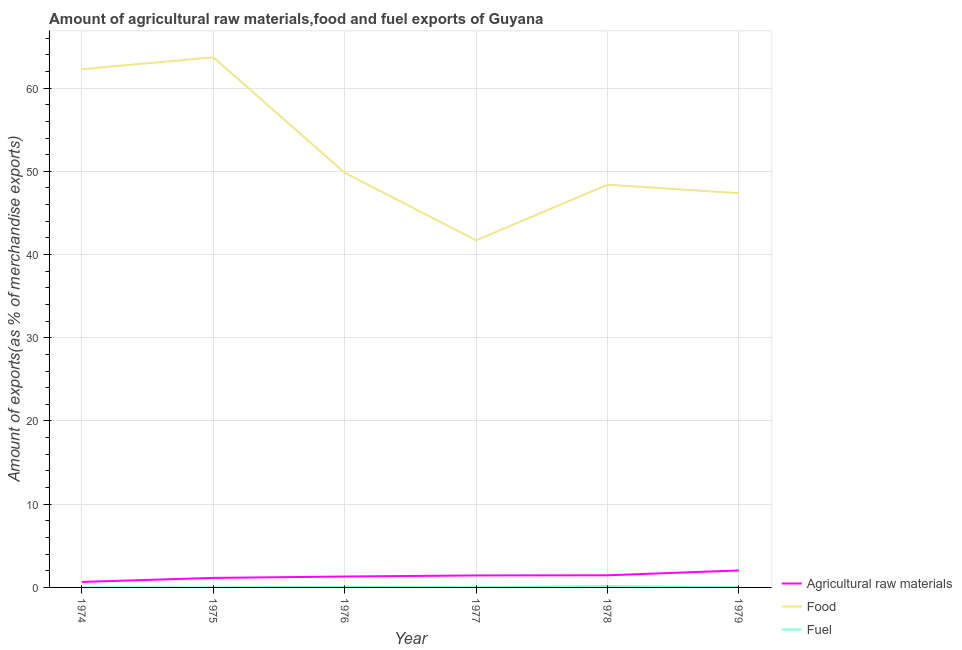Does the line corresponding to percentage of food exports intersect with the line corresponding to percentage of raw materials exports?
Make the answer very short. No. What is the percentage of fuel exports in 1979?
Your response must be concise. 0.03. Across all years, what is the maximum percentage of raw materials exports?
Offer a very short reply. 2.04. Across all years, what is the minimum percentage of fuel exports?
Your answer should be compact. 0. In which year was the percentage of fuel exports maximum?
Make the answer very short. 1978. In which year was the percentage of fuel exports minimum?
Your response must be concise. 1974. What is the total percentage of fuel exports in the graph?
Give a very brief answer. 0.27. What is the difference between the percentage of raw materials exports in 1975 and that in 1976?
Your response must be concise. -0.17. What is the difference between the percentage of fuel exports in 1977 and the percentage of raw materials exports in 1978?
Your answer should be compact. -1.44. What is the average percentage of raw materials exports per year?
Your answer should be compact. 1.34. In the year 1979, what is the difference between the percentage of food exports and percentage of raw materials exports?
Keep it short and to the point. 45.33. What is the ratio of the percentage of fuel exports in 1978 to that in 1979?
Provide a succinct answer. 6.14. Is the percentage of food exports in 1974 less than that in 1979?
Make the answer very short. No. Is the difference between the percentage of fuel exports in 1974 and 1977 greater than the difference between the percentage of raw materials exports in 1974 and 1977?
Keep it short and to the point. Yes. What is the difference between the highest and the second highest percentage of raw materials exports?
Make the answer very short. 0.58. What is the difference between the highest and the lowest percentage of fuel exports?
Give a very brief answer. 0.16. Is the sum of the percentage of fuel exports in 1974 and 1976 greater than the maximum percentage of raw materials exports across all years?
Give a very brief answer. No. Is it the case that in every year, the sum of the percentage of raw materials exports and percentage of food exports is greater than the percentage of fuel exports?
Offer a very short reply. Yes. How many lines are there?
Keep it short and to the point. 3. How many years are there in the graph?
Make the answer very short. 6. Are the values on the major ticks of Y-axis written in scientific E-notation?
Offer a very short reply. No. Does the graph contain any zero values?
Make the answer very short. No. How many legend labels are there?
Offer a very short reply. 3. How are the legend labels stacked?
Your answer should be compact. Vertical. What is the title of the graph?
Your response must be concise. Amount of agricultural raw materials,food and fuel exports of Guyana. What is the label or title of the X-axis?
Provide a succinct answer. Year. What is the label or title of the Y-axis?
Your answer should be very brief. Amount of exports(as % of merchandise exports). What is the Amount of exports(as % of merchandise exports) in Agricultural raw materials in 1974?
Your answer should be compact. 0.66. What is the Amount of exports(as % of merchandise exports) in Food in 1974?
Offer a terse response. 62.28. What is the Amount of exports(as % of merchandise exports) in Fuel in 1974?
Provide a succinct answer. 0. What is the Amount of exports(as % of merchandise exports) in Agricultural raw materials in 1975?
Offer a very short reply. 1.14. What is the Amount of exports(as % of merchandise exports) of Food in 1975?
Provide a succinct answer. 63.7. What is the Amount of exports(as % of merchandise exports) in Fuel in 1975?
Keep it short and to the point. 0. What is the Amount of exports(as % of merchandise exports) of Agricultural raw materials in 1976?
Your answer should be very brief. 1.31. What is the Amount of exports(as % of merchandise exports) of Food in 1976?
Offer a very short reply. 49.82. What is the Amount of exports(as % of merchandise exports) of Fuel in 1976?
Provide a succinct answer. 0.07. What is the Amount of exports(as % of merchandise exports) in Agricultural raw materials in 1977?
Your answer should be compact. 1.44. What is the Amount of exports(as % of merchandise exports) in Food in 1977?
Keep it short and to the point. 41.71. What is the Amount of exports(as % of merchandise exports) in Fuel in 1977?
Your answer should be compact. 0.02. What is the Amount of exports(as % of merchandise exports) in Agricultural raw materials in 1978?
Offer a very short reply. 1.46. What is the Amount of exports(as % of merchandise exports) of Food in 1978?
Make the answer very short. 48.39. What is the Amount of exports(as % of merchandise exports) in Fuel in 1978?
Provide a succinct answer. 0.16. What is the Amount of exports(as % of merchandise exports) of Agricultural raw materials in 1979?
Ensure brevity in your answer.  2.04. What is the Amount of exports(as % of merchandise exports) in Food in 1979?
Give a very brief answer. 47.37. What is the Amount of exports(as % of merchandise exports) in Fuel in 1979?
Give a very brief answer. 0.03. Across all years, what is the maximum Amount of exports(as % of merchandise exports) of Agricultural raw materials?
Keep it short and to the point. 2.04. Across all years, what is the maximum Amount of exports(as % of merchandise exports) of Food?
Your response must be concise. 63.7. Across all years, what is the maximum Amount of exports(as % of merchandise exports) of Fuel?
Keep it short and to the point. 0.16. Across all years, what is the minimum Amount of exports(as % of merchandise exports) in Agricultural raw materials?
Your response must be concise. 0.66. Across all years, what is the minimum Amount of exports(as % of merchandise exports) of Food?
Your response must be concise. 41.71. Across all years, what is the minimum Amount of exports(as % of merchandise exports) of Fuel?
Your response must be concise. 0. What is the total Amount of exports(as % of merchandise exports) of Agricultural raw materials in the graph?
Your response must be concise. 8.05. What is the total Amount of exports(as % of merchandise exports) of Food in the graph?
Offer a very short reply. 313.27. What is the total Amount of exports(as % of merchandise exports) of Fuel in the graph?
Make the answer very short. 0.27. What is the difference between the Amount of exports(as % of merchandise exports) in Agricultural raw materials in 1974 and that in 1975?
Your answer should be compact. -0.48. What is the difference between the Amount of exports(as % of merchandise exports) in Food in 1974 and that in 1975?
Give a very brief answer. -1.42. What is the difference between the Amount of exports(as % of merchandise exports) in Fuel in 1974 and that in 1975?
Offer a very short reply. -0. What is the difference between the Amount of exports(as % of merchandise exports) of Agricultural raw materials in 1974 and that in 1976?
Your answer should be very brief. -0.65. What is the difference between the Amount of exports(as % of merchandise exports) of Food in 1974 and that in 1976?
Your answer should be compact. 12.46. What is the difference between the Amount of exports(as % of merchandise exports) of Fuel in 1974 and that in 1976?
Offer a very short reply. -0.07. What is the difference between the Amount of exports(as % of merchandise exports) in Agricultural raw materials in 1974 and that in 1977?
Provide a short and direct response. -0.78. What is the difference between the Amount of exports(as % of merchandise exports) of Food in 1974 and that in 1977?
Your answer should be compact. 20.57. What is the difference between the Amount of exports(as % of merchandise exports) of Fuel in 1974 and that in 1977?
Your answer should be very brief. -0.02. What is the difference between the Amount of exports(as % of merchandise exports) in Agricultural raw materials in 1974 and that in 1978?
Ensure brevity in your answer.  -0.8. What is the difference between the Amount of exports(as % of merchandise exports) in Food in 1974 and that in 1978?
Offer a very short reply. 13.89. What is the difference between the Amount of exports(as % of merchandise exports) in Fuel in 1974 and that in 1978?
Provide a succinct answer. -0.16. What is the difference between the Amount of exports(as % of merchandise exports) of Agricultural raw materials in 1974 and that in 1979?
Ensure brevity in your answer.  -1.38. What is the difference between the Amount of exports(as % of merchandise exports) in Food in 1974 and that in 1979?
Offer a terse response. 14.91. What is the difference between the Amount of exports(as % of merchandise exports) of Fuel in 1974 and that in 1979?
Keep it short and to the point. -0.03. What is the difference between the Amount of exports(as % of merchandise exports) of Agricultural raw materials in 1975 and that in 1976?
Your response must be concise. -0.17. What is the difference between the Amount of exports(as % of merchandise exports) in Food in 1975 and that in 1976?
Provide a succinct answer. 13.88. What is the difference between the Amount of exports(as % of merchandise exports) of Fuel in 1975 and that in 1976?
Ensure brevity in your answer.  -0.07. What is the difference between the Amount of exports(as % of merchandise exports) of Agricultural raw materials in 1975 and that in 1977?
Give a very brief answer. -0.3. What is the difference between the Amount of exports(as % of merchandise exports) of Food in 1975 and that in 1977?
Make the answer very short. 21.99. What is the difference between the Amount of exports(as % of merchandise exports) in Fuel in 1975 and that in 1977?
Offer a very short reply. -0.02. What is the difference between the Amount of exports(as % of merchandise exports) in Agricultural raw materials in 1975 and that in 1978?
Keep it short and to the point. -0.31. What is the difference between the Amount of exports(as % of merchandise exports) in Food in 1975 and that in 1978?
Provide a short and direct response. 15.31. What is the difference between the Amount of exports(as % of merchandise exports) in Fuel in 1975 and that in 1978?
Make the answer very short. -0.16. What is the difference between the Amount of exports(as % of merchandise exports) in Agricultural raw materials in 1975 and that in 1979?
Your answer should be compact. -0.9. What is the difference between the Amount of exports(as % of merchandise exports) of Food in 1975 and that in 1979?
Your answer should be very brief. 16.33. What is the difference between the Amount of exports(as % of merchandise exports) in Fuel in 1975 and that in 1979?
Give a very brief answer. -0.03. What is the difference between the Amount of exports(as % of merchandise exports) in Agricultural raw materials in 1976 and that in 1977?
Offer a very short reply. -0.13. What is the difference between the Amount of exports(as % of merchandise exports) in Food in 1976 and that in 1977?
Give a very brief answer. 8.11. What is the difference between the Amount of exports(as % of merchandise exports) in Fuel in 1976 and that in 1977?
Give a very brief answer. 0.05. What is the difference between the Amount of exports(as % of merchandise exports) of Agricultural raw materials in 1976 and that in 1978?
Your answer should be compact. -0.15. What is the difference between the Amount of exports(as % of merchandise exports) of Food in 1976 and that in 1978?
Provide a succinct answer. 1.43. What is the difference between the Amount of exports(as % of merchandise exports) in Fuel in 1976 and that in 1978?
Offer a very short reply. -0.09. What is the difference between the Amount of exports(as % of merchandise exports) of Agricultural raw materials in 1976 and that in 1979?
Offer a very short reply. -0.73. What is the difference between the Amount of exports(as % of merchandise exports) in Food in 1976 and that in 1979?
Your answer should be compact. 2.45. What is the difference between the Amount of exports(as % of merchandise exports) of Fuel in 1976 and that in 1979?
Give a very brief answer. 0.04. What is the difference between the Amount of exports(as % of merchandise exports) of Agricultural raw materials in 1977 and that in 1978?
Your answer should be compact. -0.02. What is the difference between the Amount of exports(as % of merchandise exports) of Food in 1977 and that in 1978?
Offer a very short reply. -6.68. What is the difference between the Amount of exports(as % of merchandise exports) of Fuel in 1977 and that in 1978?
Offer a very short reply. -0.14. What is the difference between the Amount of exports(as % of merchandise exports) of Agricultural raw materials in 1977 and that in 1979?
Your response must be concise. -0.6. What is the difference between the Amount of exports(as % of merchandise exports) in Food in 1977 and that in 1979?
Give a very brief answer. -5.66. What is the difference between the Amount of exports(as % of merchandise exports) in Fuel in 1977 and that in 1979?
Ensure brevity in your answer.  -0. What is the difference between the Amount of exports(as % of merchandise exports) of Agricultural raw materials in 1978 and that in 1979?
Make the answer very short. -0.58. What is the difference between the Amount of exports(as % of merchandise exports) in Food in 1978 and that in 1979?
Your response must be concise. 1.02. What is the difference between the Amount of exports(as % of merchandise exports) of Fuel in 1978 and that in 1979?
Offer a terse response. 0.13. What is the difference between the Amount of exports(as % of merchandise exports) of Agricultural raw materials in 1974 and the Amount of exports(as % of merchandise exports) of Food in 1975?
Your answer should be compact. -63.04. What is the difference between the Amount of exports(as % of merchandise exports) in Agricultural raw materials in 1974 and the Amount of exports(as % of merchandise exports) in Fuel in 1975?
Give a very brief answer. 0.66. What is the difference between the Amount of exports(as % of merchandise exports) of Food in 1974 and the Amount of exports(as % of merchandise exports) of Fuel in 1975?
Your answer should be very brief. 62.28. What is the difference between the Amount of exports(as % of merchandise exports) of Agricultural raw materials in 1974 and the Amount of exports(as % of merchandise exports) of Food in 1976?
Give a very brief answer. -49.16. What is the difference between the Amount of exports(as % of merchandise exports) in Agricultural raw materials in 1974 and the Amount of exports(as % of merchandise exports) in Fuel in 1976?
Give a very brief answer. 0.59. What is the difference between the Amount of exports(as % of merchandise exports) in Food in 1974 and the Amount of exports(as % of merchandise exports) in Fuel in 1976?
Offer a terse response. 62.21. What is the difference between the Amount of exports(as % of merchandise exports) of Agricultural raw materials in 1974 and the Amount of exports(as % of merchandise exports) of Food in 1977?
Ensure brevity in your answer.  -41.05. What is the difference between the Amount of exports(as % of merchandise exports) in Agricultural raw materials in 1974 and the Amount of exports(as % of merchandise exports) in Fuel in 1977?
Make the answer very short. 0.64. What is the difference between the Amount of exports(as % of merchandise exports) in Food in 1974 and the Amount of exports(as % of merchandise exports) in Fuel in 1977?
Ensure brevity in your answer.  62.26. What is the difference between the Amount of exports(as % of merchandise exports) of Agricultural raw materials in 1974 and the Amount of exports(as % of merchandise exports) of Food in 1978?
Your response must be concise. -47.73. What is the difference between the Amount of exports(as % of merchandise exports) of Agricultural raw materials in 1974 and the Amount of exports(as % of merchandise exports) of Fuel in 1978?
Make the answer very short. 0.5. What is the difference between the Amount of exports(as % of merchandise exports) of Food in 1974 and the Amount of exports(as % of merchandise exports) of Fuel in 1978?
Keep it short and to the point. 62.12. What is the difference between the Amount of exports(as % of merchandise exports) of Agricultural raw materials in 1974 and the Amount of exports(as % of merchandise exports) of Food in 1979?
Make the answer very short. -46.71. What is the difference between the Amount of exports(as % of merchandise exports) of Agricultural raw materials in 1974 and the Amount of exports(as % of merchandise exports) of Fuel in 1979?
Make the answer very short. 0.63. What is the difference between the Amount of exports(as % of merchandise exports) of Food in 1974 and the Amount of exports(as % of merchandise exports) of Fuel in 1979?
Give a very brief answer. 62.25. What is the difference between the Amount of exports(as % of merchandise exports) in Agricultural raw materials in 1975 and the Amount of exports(as % of merchandise exports) in Food in 1976?
Keep it short and to the point. -48.68. What is the difference between the Amount of exports(as % of merchandise exports) of Agricultural raw materials in 1975 and the Amount of exports(as % of merchandise exports) of Fuel in 1976?
Your answer should be very brief. 1.08. What is the difference between the Amount of exports(as % of merchandise exports) in Food in 1975 and the Amount of exports(as % of merchandise exports) in Fuel in 1976?
Make the answer very short. 63.63. What is the difference between the Amount of exports(as % of merchandise exports) in Agricultural raw materials in 1975 and the Amount of exports(as % of merchandise exports) in Food in 1977?
Give a very brief answer. -40.56. What is the difference between the Amount of exports(as % of merchandise exports) in Agricultural raw materials in 1975 and the Amount of exports(as % of merchandise exports) in Fuel in 1977?
Your response must be concise. 1.12. What is the difference between the Amount of exports(as % of merchandise exports) in Food in 1975 and the Amount of exports(as % of merchandise exports) in Fuel in 1977?
Your response must be concise. 63.68. What is the difference between the Amount of exports(as % of merchandise exports) of Agricultural raw materials in 1975 and the Amount of exports(as % of merchandise exports) of Food in 1978?
Make the answer very short. -47.25. What is the difference between the Amount of exports(as % of merchandise exports) of Agricultural raw materials in 1975 and the Amount of exports(as % of merchandise exports) of Fuel in 1978?
Your answer should be very brief. 0.99. What is the difference between the Amount of exports(as % of merchandise exports) in Food in 1975 and the Amount of exports(as % of merchandise exports) in Fuel in 1978?
Provide a short and direct response. 63.54. What is the difference between the Amount of exports(as % of merchandise exports) of Agricultural raw materials in 1975 and the Amount of exports(as % of merchandise exports) of Food in 1979?
Provide a short and direct response. -46.23. What is the difference between the Amount of exports(as % of merchandise exports) in Agricultural raw materials in 1975 and the Amount of exports(as % of merchandise exports) in Fuel in 1979?
Your answer should be very brief. 1.12. What is the difference between the Amount of exports(as % of merchandise exports) in Food in 1975 and the Amount of exports(as % of merchandise exports) in Fuel in 1979?
Give a very brief answer. 63.67. What is the difference between the Amount of exports(as % of merchandise exports) of Agricultural raw materials in 1976 and the Amount of exports(as % of merchandise exports) of Food in 1977?
Give a very brief answer. -40.4. What is the difference between the Amount of exports(as % of merchandise exports) of Agricultural raw materials in 1976 and the Amount of exports(as % of merchandise exports) of Fuel in 1977?
Your answer should be compact. 1.29. What is the difference between the Amount of exports(as % of merchandise exports) of Food in 1976 and the Amount of exports(as % of merchandise exports) of Fuel in 1977?
Provide a short and direct response. 49.8. What is the difference between the Amount of exports(as % of merchandise exports) of Agricultural raw materials in 1976 and the Amount of exports(as % of merchandise exports) of Food in 1978?
Ensure brevity in your answer.  -47.08. What is the difference between the Amount of exports(as % of merchandise exports) of Agricultural raw materials in 1976 and the Amount of exports(as % of merchandise exports) of Fuel in 1978?
Give a very brief answer. 1.15. What is the difference between the Amount of exports(as % of merchandise exports) in Food in 1976 and the Amount of exports(as % of merchandise exports) in Fuel in 1978?
Your answer should be very brief. 49.66. What is the difference between the Amount of exports(as % of merchandise exports) in Agricultural raw materials in 1976 and the Amount of exports(as % of merchandise exports) in Food in 1979?
Provide a succinct answer. -46.06. What is the difference between the Amount of exports(as % of merchandise exports) in Agricultural raw materials in 1976 and the Amount of exports(as % of merchandise exports) in Fuel in 1979?
Offer a terse response. 1.29. What is the difference between the Amount of exports(as % of merchandise exports) in Food in 1976 and the Amount of exports(as % of merchandise exports) in Fuel in 1979?
Make the answer very short. 49.8. What is the difference between the Amount of exports(as % of merchandise exports) in Agricultural raw materials in 1977 and the Amount of exports(as % of merchandise exports) in Food in 1978?
Provide a short and direct response. -46.95. What is the difference between the Amount of exports(as % of merchandise exports) of Agricultural raw materials in 1977 and the Amount of exports(as % of merchandise exports) of Fuel in 1978?
Offer a terse response. 1.28. What is the difference between the Amount of exports(as % of merchandise exports) of Food in 1977 and the Amount of exports(as % of merchandise exports) of Fuel in 1978?
Your response must be concise. 41.55. What is the difference between the Amount of exports(as % of merchandise exports) of Agricultural raw materials in 1977 and the Amount of exports(as % of merchandise exports) of Food in 1979?
Make the answer very short. -45.93. What is the difference between the Amount of exports(as % of merchandise exports) of Agricultural raw materials in 1977 and the Amount of exports(as % of merchandise exports) of Fuel in 1979?
Ensure brevity in your answer.  1.42. What is the difference between the Amount of exports(as % of merchandise exports) of Food in 1977 and the Amount of exports(as % of merchandise exports) of Fuel in 1979?
Make the answer very short. 41.68. What is the difference between the Amount of exports(as % of merchandise exports) in Agricultural raw materials in 1978 and the Amount of exports(as % of merchandise exports) in Food in 1979?
Your answer should be compact. -45.91. What is the difference between the Amount of exports(as % of merchandise exports) of Agricultural raw materials in 1978 and the Amount of exports(as % of merchandise exports) of Fuel in 1979?
Keep it short and to the point. 1.43. What is the difference between the Amount of exports(as % of merchandise exports) in Food in 1978 and the Amount of exports(as % of merchandise exports) in Fuel in 1979?
Give a very brief answer. 48.37. What is the average Amount of exports(as % of merchandise exports) in Agricultural raw materials per year?
Your answer should be very brief. 1.34. What is the average Amount of exports(as % of merchandise exports) in Food per year?
Your answer should be very brief. 52.21. What is the average Amount of exports(as % of merchandise exports) of Fuel per year?
Your response must be concise. 0.04. In the year 1974, what is the difference between the Amount of exports(as % of merchandise exports) in Agricultural raw materials and Amount of exports(as % of merchandise exports) in Food?
Provide a short and direct response. -61.62. In the year 1974, what is the difference between the Amount of exports(as % of merchandise exports) of Agricultural raw materials and Amount of exports(as % of merchandise exports) of Fuel?
Ensure brevity in your answer.  0.66. In the year 1974, what is the difference between the Amount of exports(as % of merchandise exports) in Food and Amount of exports(as % of merchandise exports) in Fuel?
Give a very brief answer. 62.28. In the year 1975, what is the difference between the Amount of exports(as % of merchandise exports) of Agricultural raw materials and Amount of exports(as % of merchandise exports) of Food?
Your response must be concise. -62.55. In the year 1975, what is the difference between the Amount of exports(as % of merchandise exports) of Agricultural raw materials and Amount of exports(as % of merchandise exports) of Fuel?
Provide a succinct answer. 1.14. In the year 1975, what is the difference between the Amount of exports(as % of merchandise exports) in Food and Amount of exports(as % of merchandise exports) in Fuel?
Give a very brief answer. 63.7. In the year 1976, what is the difference between the Amount of exports(as % of merchandise exports) in Agricultural raw materials and Amount of exports(as % of merchandise exports) in Food?
Ensure brevity in your answer.  -48.51. In the year 1976, what is the difference between the Amount of exports(as % of merchandise exports) of Agricultural raw materials and Amount of exports(as % of merchandise exports) of Fuel?
Ensure brevity in your answer.  1.25. In the year 1976, what is the difference between the Amount of exports(as % of merchandise exports) in Food and Amount of exports(as % of merchandise exports) in Fuel?
Your response must be concise. 49.76. In the year 1977, what is the difference between the Amount of exports(as % of merchandise exports) of Agricultural raw materials and Amount of exports(as % of merchandise exports) of Food?
Make the answer very short. -40.27. In the year 1977, what is the difference between the Amount of exports(as % of merchandise exports) in Agricultural raw materials and Amount of exports(as % of merchandise exports) in Fuel?
Offer a terse response. 1.42. In the year 1977, what is the difference between the Amount of exports(as % of merchandise exports) in Food and Amount of exports(as % of merchandise exports) in Fuel?
Provide a short and direct response. 41.69. In the year 1978, what is the difference between the Amount of exports(as % of merchandise exports) of Agricultural raw materials and Amount of exports(as % of merchandise exports) of Food?
Give a very brief answer. -46.94. In the year 1978, what is the difference between the Amount of exports(as % of merchandise exports) in Agricultural raw materials and Amount of exports(as % of merchandise exports) in Fuel?
Offer a very short reply. 1.3. In the year 1978, what is the difference between the Amount of exports(as % of merchandise exports) in Food and Amount of exports(as % of merchandise exports) in Fuel?
Your answer should be compact. 48.24. In the year 1979, what is the difference between the Amount of exports(as % of merchandise exports) in Agricultural raw materials and Amount of exports(as % of merchandise exports) in Food?
Provide a succinct answer. -45.33. In the year 1979, what is the difference between the Amount of exports(as % of merchandise exports) in Agricultural raw materials and Amount of exports(as % of merchandise exports) in Fuel?
Give a very brief answer. 2.01. In the year 1979, what is the difference between the Amount of exports(as % of merchandise exports) in Food and Amount of exports(as % of merchandise exports) in Fuel?
Provide a short and direct response. 47.34. What is the ratio of the Amount of exports(as % of merchandise exports) of Agricultural raw materials in 1974 to that in 1975?
Your answer should be very brief. 0.58. What is the ratio of the Amount of exports(as % of merchandise exports) of Food in 1974 to that in 1975?
Provide a succinct answer. 0.98. What is the ratio of the Amount of exports(as % of merchandise exports) of Fuel in 1974 to that in 1975?
Your answer should be very brief. 0.52. What is the ratio of the Amount of exports(as % of merchandise exports) of Agricultural raw materials in 1974 to that in 1976?
Provide a short and direct response. 0.5. What is the ratio of the Amount of exports(as % of merchandise exports) in Food in 1974 to that in 1976?
Provide a short and direct response. 1.25. What is the ratio of the Amount of exports(as % of merchandise exports) in Fuel in 1974 to that in 1976?
Ensure brevity in your answer.  0. What is the ratio of the Amount of exports(as % of merchandise exports) of Agricultural raw materials in 1974 to that in 1977?
Your response must be concise. 0.46. What is the ratio of the Amount of exports(as % of merchandise exports) in Food in 1974 to that in 1977?
Ensure brevity in your answer.  1.49. What is the ratio of the Amount of exports(as % of merchandise exports) in Fuel in 1974 to that in 1977?
Your response must be concise. 0.01. What is the ratio of the Amount of exports(as % of merchandise exports) in Agricultural raw materials in 1974 to that in 1978?
Ensure brevity in your answer.  0.45. What is the ratio of the Amount of exports(as % of merchandise exports) of Food in 1974 to that in 1978?
Provide a short and direct response. 1.29. What is the ratio of the Amount of exports(as % of merchandise exports) in Fuel in 1974 to that in 1978?
Keep it short and to the point. 0. What is the ratio of the Amount of exports(as % of merchandise exports) in Agricultural raw materials in 1974 to that in 1979?
Provide a short and direct response. 0.32. What is the ratio of the Amount of exports(as % of merchandise exports) in Food in 1974 to that in 1979?
Offer a very short reply. 1.31. What is the ratio of the Amount of exports(as % of merchandise exports) in Fuel in 1974 to that in 1979?
Your response must be concise. 0.01. What is the ratio of the Amount of exports(as % of merchandise exports) in Agricultural raw materials in 1975 to that in 1976?
Your answer should be compact. 0.87. What is the ratio of the Amount of exports(as % of merchandise exports) of Food in 1975 to that in 1976?
Provide a short and direct response. 1.28. What is the ratio of the Amount of exports(as % of merchandise exports) in Fuel in 1975 to that in 1976?
Offer a terse response. 0.01. What is the ratio of the Amount of exports(as % of merchandise exports) of Agricultural raw materials in 1975 to that in 1977?
Offer a very short reply. 0.79. What is the ratio of the Amount of exports(as % of merchandise exports) in Food in 1975 to that in 1977?
Provide a short and direct response. 1.53. What is the ratio of the Amount of exports(as % of merchandise exports) in Fuel in 1975 to that in 1977?
Your answer should be very brief. 0.02. What is the ratio of the Amount of exports(as % of merchandise exports) in Agricultural raw materials in 1975 to that in 1978?
Your response must be concise. 0.79. What is the ratio of the Amount of exports(as % of merchandise exports) of Food in 1975 to that in 1978?
Offer a terse response. 1.32. What is the ratio of the Amount of exports(as % of merchandise exports) in Fuel in 1975 to that in 1978?
Give a very brief answer. 0. What is the ratio of the Amount of exports(as % of merchandise exports) of Agricultural raw materials in 1975 to that in 1979?
Your response must be concise. 0.56. What is the ratio of the Amount of exports(as % of merchandise exports) in Food in 1975 to that in 1979?
Offer a terse response. 1.34. What is the ratio of the Amount of exports(as % of merchandise exports) in Fuel in 1975 to that in 1979?
Your answer should be compact. 0.02. What is the ratio of the Amount of exports(as % of merchandise exports) in Agricultural raw materials in 1976 to that in 1977?
Provide a short and direct response. 0.91. What is the ratio of the Amount of exports(as % of merchandise exports) in Food in 1976 to that in 1977?
Make the answer very short. 1.19. What is the ratio of the Amount of exports(as % of merchandise exports) in Fuel in 1976 to that in 1977?
Provide a succinct answer. 3.17. What is the ratio of the Amount of exports(as % of merchandise exports) in Agricultural raw materials in 1976 to that in 1978?
Keep it short and to the point. 0.9. What is the ratio of the Amount of exports(as % of merchandise exports) in Food in 1976 to that in 1978?
Give a very brief answer. 1.03. What is the ratio of the Amount of exports(as % of merchandise exports) of Fuel in 1976 to that in 1978?
Keep it short and to the point. 0.42. What is the ratio of the Amount of exports(as % of merchandise exports) in Agricultural raw materials in 1976 to that in 1979?
Provide a succinct answer. 0.64. What is the ratio of the Amount of exports(as % of merchandise exports) in Food in 1976 to that in 1979?
Provide a succinct answer. 1.05. What is the ratio of the Amount of exports(as % of merchandise exports) in Fuel in 1976 to that in 1979?
Your answer should be compact. 2.57. What is the ratio of the Amount of exports(as % of merchandise exports) of Food in 1977 to that in 1978?
Your response must be concise. 0.86. What is the ratio of the Amount of exports(as % of merchandise exports) in Fuel in 1977 to that in 1978?
Provide a short and direct response. 0.13. What is the ratio of the Amount of exports(as % of merchandise exports) in Agricultural raw materials in 1977 to that in 1979?
Provide a short and direct response. 0.71. What is the ratio of the Amount of exports(as % of merchandise exports) in Food in 1977 to that in 1979?
Ensure brevity in your answer.  0.88. What is the ratio of the Amount of exports(as % of merchandise exports) of Fuel in 1977 to that in 1979?
Give a very brief answer. 0.81. What is the ratio of the Amount of exports(as % of merchandise exports) of Agricultural raw materials in 1978 to that in 1979?
Keep it short and to the point. 0.71. What is the ratio of the Amount of exports(as % of merchandise exports) of Food in 1978 to that in 1979?
Your response must be concise. 1.02. What is the ratio of the Amount of exports(as % of merchandise exports) of Fuel in 1978 to that in 1979?
Your response must be concise. 6.14. What is the difference between the highest and the second highest Amount of exports(as % of merchandise exports) in Agricultural raw materials?
Keep it short and to the point. 0.58. What is the difference between the highest and the second highest Amount of exports(as % of merchandise exports) of Food?
Keep it short and to the point. 1.42. What is the difference between the highest and the second highest Amount of exports(as % of merchandise exports) in Fuel?
Your answer should be compact. 0.09. What is the difference between the highest and the lowest Amount of exports(as % of merchandise exports) of Agricultural raw materials?
Offer a very short reply. 1.38. What is the difference between the highest and the lowest Amount of exports(as % of merchandise exports) in Food?
Provide a short and direct response. 21.99. What is the difference between the highest and the lowest Amount of exports(as % of merchandise exports) in Fuel?
Offer a very short reply. 0.16. 